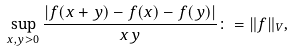Convert formula to latex. <formula><loc_0><loc_0><loc_500><loc_500>\sup _ { x , y > 0 } \frac { | f ( x + y ) - f ( x ) - f ( y ) | } { x y } \colon = \| f \| _ { V } ,</formula> 